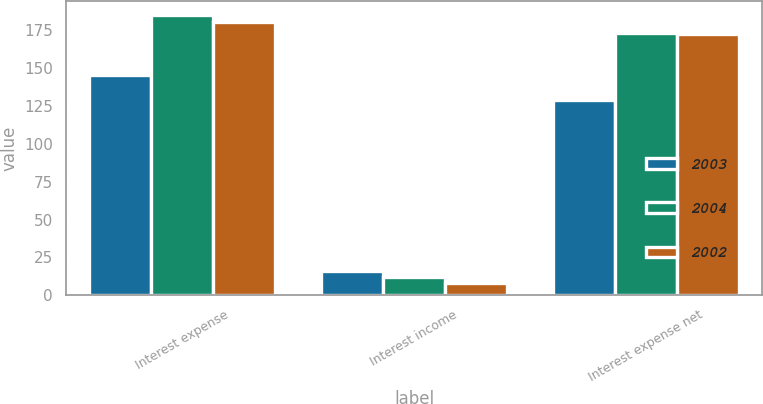Convert chart. <chart><loc_0><loc_0><loc_500><loc_500><stacked_bar_chart><ecel><fcel>Interest expense<fcel>Interest income<fcel>Interest expense net<nl><fcel>2003<fcel>145<fcel>16<fcel>129<nl><fcel>2004<fcel>185<fcel>12<fcel>173<nl><fcel>2002<fcel>180<fcel>8<fcel>172<nl></chart> 